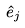Convert formula to latex. <formula><loc_0><loc_0><loc_500><loc_500>\hat { e } _ { j }</formula> 